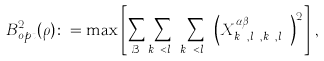Convert formula to latex. <formula><loc_0><loc_0><loc_500><loc_500>B ^ { 2 } _ { o p t } ( \rho ) \colon = \max \left [ \sum _ { \mathcal { B } } \sum _ { k _ { A } < l _ { A } } \sum _ { k _ { B } < l _ { B } } \left ( X ^ { \alpha \beta } _ { k _ { A } , l _ { A } , k _ { B } , l _ { B } } \right ) ^ { 2 } \right ] \, ,</formula> 